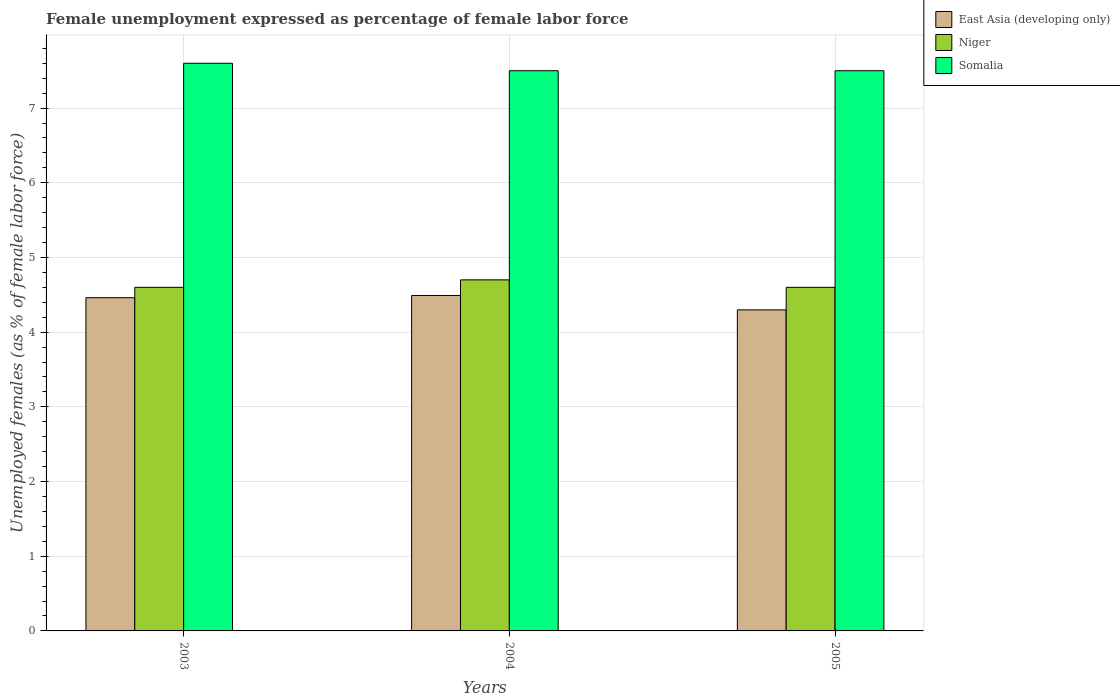How many different coloured bars are there?
Your answer should be very brief. 3. Are the number of bars on each tick of the X-axis equal?
Provide a short and direct response. Yes. How many bars are there on the 3rd tick from the left?
Offer a terse response. 3. In how many cases, is the number of bars for a given year not equal to the number of legend labels?
Your answer should be compact. 0. What is the unemployment in females in in Somalia in 2003?
Offer a terse response. 7.6. Across all years, what is the maximum unemployment in females in in East Asia (developing only)?
Your answer should be very brief. 4.49. Across all years, what is the minimum unemployment in females in in East Asia (developing only)?
Offer a terse response. 4.3. In which year was the unemployment in females in in Somalia maximum?
Provide a succinct answer. 2003. What is the total unemployment in females in in Somalia in the graph?
Provide a succinct answer. 22.6. What is the difference between the unemployment in females in in East Asia (developing only) in 2004 and that in 2005?
Provide a succinct answer. 0.19. What is the difference between the unemployment in females in in Niger in 2005 and the unemployment in females in in East Asia (developing only) in 2003?
Make the answer very short. 0.14. What is the average unemployment in females in in Somalia per year?
Offer a very short reply. 7.53. In the year 2005, what is the difference between the unemployment in females in in Niger and unemployment in females in in Somalia?
Ensure brevity in your answer.  -2.9. In how many years, is the unemployment in females in in Niger greater than 4.4 %?
Ensure brevity in your answer.  3. What is the ratio of the unemployment in females in in East Asia (developing only) in 2003 to that in 2004?
Give a very brief answer. 0.99. Is the unemployment in females in in East Asia (developing only) in 2003 less than that in 2005?
Offer a terse response. No. Is the difference between the unemployment in females in in Niger in 2003 and 2005 greater than the difference between the unemployment in females in in Somalia in 2003 and 2005?
Ensure brevity in your answer.  No. What is the difference between the highest and the second highest unemployment in females in in Niger?
Your answer should be very brief. 0.1. What is the difference between the highest and the lowest unemployment in females in in Somalia?
Give a very brief answer. 0.1. In how many years, is the unemployment in females in in East Asia (developing only) greater than the average unemployment in females in in East Asia (developing only) taken over all years?
Offer a very short reply. 2. Is the sum of the unemployment in females in in East Asia (developing only) in 2004 and 2005 greater than the maximum unemployment in females in in Somalia across all years?
Your response must be concise. Yes. What does the 3rd bar from the left in 2005 represents?
Ensure brevity in your answer.  Somalia. What does the 2nd bar from the right in 2004 represents?
Your answer should be very brief. Niger. Is it the case that in every year, the sum of the unemployment in females in in Somalia and unemployment in females in in Niger is greater than the unemployment in females in in East Asia (developing only)?
Your answer should be very brief. Yes. What is the difference between two consecutive major ticks on the Y-axis?
Your response must be concise. 1. Does the graph contain any zero values?
Provide a succinct answer. No. Does the graph contain grids?
Keep it short and to the point. Yes. How many legend labels are there?
Your response must be concise. 3. What is the title of the graph?
Ensure brevity in your answer.  Female unemployment expressed as percentage of female labor force. Does "Congo (Democratic)" appear as one of the legend labels in the graph?
Your answer should be very brief. No. What is the label or title of the Y-axis?
Your answer should be compact. Unemployed females (as % of female labor force). What is the Unemployed females (as % of female labor force) in East Asia (developing only) in 2003?
Offer a very short reply. 4.46. What is the Unemployed females (as % of female labor force) of Niger in 2003?
Your response must be concise. 4.6. What is the Unemployed females (as % of female labor force) in Somalia in 2003?
Provide a short and direct response. 7.6. What is the Unemployed females (as % of female labor force) of East Asia (developing only) in 2004?
Provide a succinct answer. 4.49. What is the Unemployed females (as % of female labor force) of Niger in 2004?
Your response must be concise. 4.7. What is the Unemployed females (as % of female labor force) in Somalia in 2004?
Your answer should be compact. 7.5. What is the Unemployed females (as % of female labor force) in East Asia (developing only) in 2005?
Offer a terse response. 4.3. What is the Unemployed females (as % of female labor force) of Niger in 2005?
Ensure brevity in your answer.  4.6. Across all years, what is the maximum Unemployed females (as % of female labor force) of East Asia (developing only)?
Give a very brief answer. 4.49. Across all years, what is the maximum Unemployed females (as % of female labor force) in Niger?
Give a very brief answer. 4.7. Across all years, what is the maximum Unemployed females (as % of female labor force) in Somalia?
Provide a short and direct response. 7.6. Across all years, what is the minimum Unemployed females (as % of female labor force) in East Asia (developing only)?
Provide a succinct answer. 4.3. Across all years, what is the minimum Unemployed females (as % of female labor force) of Niger?
Keep it short and to the point. 4.6. What is the total Unemployed females (as % of female labor force) in East Asia (developing only) in the graph?
Provide a succinct answer. 13.25. What is the total Unemployed females (as % of female labor force) of Niger in the graph?
Make the answer very short. 13.9. What is the total Unemployed females (as % of female labor force) in Somalia in the graph?
Give a very brief answer. 22.6. What is the difference between the Unemployed females (as % of female labor force) of East Asia (developing only) in 2003 and that in 2004?
Offer a terse response. -0.03. What is the difference between the Unemployed females (as % of female labor force) in Niger in 2003 and that in 2004?
Your answer should be compact. -0.1. What is the difference between the Unemployed females (as % of female labor force) in Somalia in 2003 and that in 2004?
Ensure brevity in your answer.  0.1. What is the difference between the Unemployed females (as % of female labor force) in East Asia (developing only) in 2003 and that in 2005?
Provide a short and direct response. 0.16. What is the difference between the Unemployed females (as % of female labor force) of Niger in 2003 and that in 2005?
Ensure brevity in your answer.  0. What is the difference between the Unemployed females (as % of female labor force) of East Asia (developing only) in 2004 and that in 2005?
Keep it short and to the point. 0.19. What is the difference between the Unemployed females (as % of female labor force) in Niger in 2004 and that in 2005?
Make the answer very short. 0.1. What is the difference between the Unemployed females (as % of female labor force) of East Asia (developing only) in 2003 and the Unemployed females (as % of female labor force) of Niger in 2004?
Your answer should be compact. -0.24. What is the difference between the Unemployed females (as % of female labor force) of East Asia (developing only) in 2003 and the Unemployed females (as % of female labor force) of Somalia in 2004?
Your answer should be compact. -3.04. What is the difference between the Unemployed females (as % of female labor force) in East Asia (developing only) in 2003 and the Unemployed females (as % of female labor force) in Niger in 2005?
Make the answer very short. -0.14. What is the difference between the Unemployed females (as % of female labor force) of East Asia (developing only) in 2003 and the Unemployed females (as % of female labor force) of Somalia in 2005?
Keep it short and to the point. -3.04. What is the difference between the Unemployed females (as % of female labor force) in East Asia (developing only) in 2004 and the Unemployed females (as % of female labor force) in Niger in 2005?
Your answer should be very brief. -0.11. What is the difference between the Unemployed females (as % of female labor force) in East Asia (developing only) in 2004 and the Unemployed females (as % of female labor force) in Somalia in 2005?
Your response must be concise. -3.01. What is the difference between the Unemployed females (as % of female labor force) of Niger in 2004 and the Unemployed females (as % of female labor force) of Somalia in 2005?
Your answer should be very brief. -2.8. What is the average Unemployed females (as % of female labor force) of East Asia (developing only) per year?
Offer a very short reply. 4.42. What is the average Unemployed females (as % of female labor force) in Niger per year?
Keep it short and to the point. 4.63. What is the average Unemployed females (as % of female labor force) in Somalia per year?
Your response must be concise. 7.53. In the year 2003, what is the difference between the Unemployed females (as % of female labor force) in East Asia (developing only) and Unemployed females (as % of female labor force) in Niger?
Offer a very short reply. -0.14. In the year 2003, what is the difference between the Unemployed females (as % of female labor force) of East Asia (developing only) and Unemployed females (as % of female labor force) of Somalia?
Make the answer very short. -3.14. In the year 2003, what is the difference between the Unemployed females (as % of female labor force) in Niger and Unemployed females (as % of female labor force) in Somalia?
Your response must be concise. -3. In the year 2004, what is the difference between the Unemployed females (as % of female labor force) in East Asia (developing only) and Unemployed females (as % of female labor force) in Niger?
Your response must be concise. -0.21. In the year 2004, what is the difference between the Unemployed females (as % of female labor force) in East Asia (developing only) and Unemployed females (as % of female labor force) in Somalia?
Offer a very short reply. -3.01. In the year 2005, what is the difference between the Unemployed females (as % of female labor force) of East Asia (developing only) and Unemployed females (as % of female labor force) of Niger?
Your response must be concise. -0.3. In the year 2005, what is the difference between the Unemployed females (as % of female labor force) in East Asia (developing only) and Unemployed females (as % of female labor force) in Somalia?
Provide a short and direct response. -3.2. What is the ratio of the Unemployed females (as % of female labor force) in Niger in 2003 to that in 2004?
Offer a very short reply. 0.98. What is the ratio of the Unemployed females (as % of female labor force) of Somalia in 2003 to that in 2004?
Your response must be concise. 1.01. What is the ratio of the Unemployed females (as % of female labor force) in East Asia (developing only) in 2003 to that in 2005?
Ensure brevity in your answer.  1.04. What is the ratio of the Unemployed females (as % of female labor force) of Somalia in 2003 to that in 2005?
Your answer should be very brief. 1.01. What is the ratio of the Unemployed females (as % of female labor force) of East Asia (developing only) in 2004 to that in 2005?
Your answer should be compact. 1.04. What is the ratio of the Unemployed females (as % of female labor force) in Niger in 2004 to that in 2005?
Provide a succinct answer. 1.02. What is the ratio of the Unemployed females (as % of female labor force) in Somalia in 2004 to that in 2005?
Make the answer very short. 1. What is the difference between the highest and the second highest Unemployed females (as % of female labor force) in East Asia (developing only)?
Keep it short and to the point. 0.03. What is the difference between the highest and the second highest Unemployed females (as % of female labor force) of Somalia?
Give a very brief answer. 0.1. What is the difference between the highest and the lowest Unemployed females (as % of female labor force) in East Asia (developing only)?
Provide a short and direct response. 0.19. What is the difference between the highest and the lowest Unemployed females (as % of female labor force) of Somalia?
Ensure brevity in your answer.  0.1. 